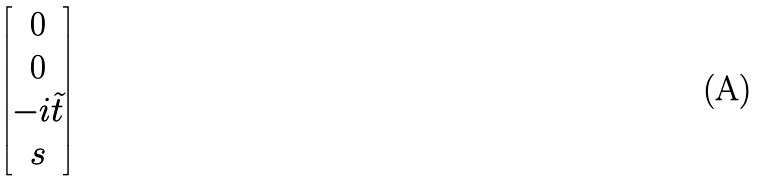<formula> <loc_0><loc_0><loc_500><loc_500>\begin{bmatrix} 0 \\ 0 \\ - i \tilde { t } \\ s \end{bmatrix}</formula> 